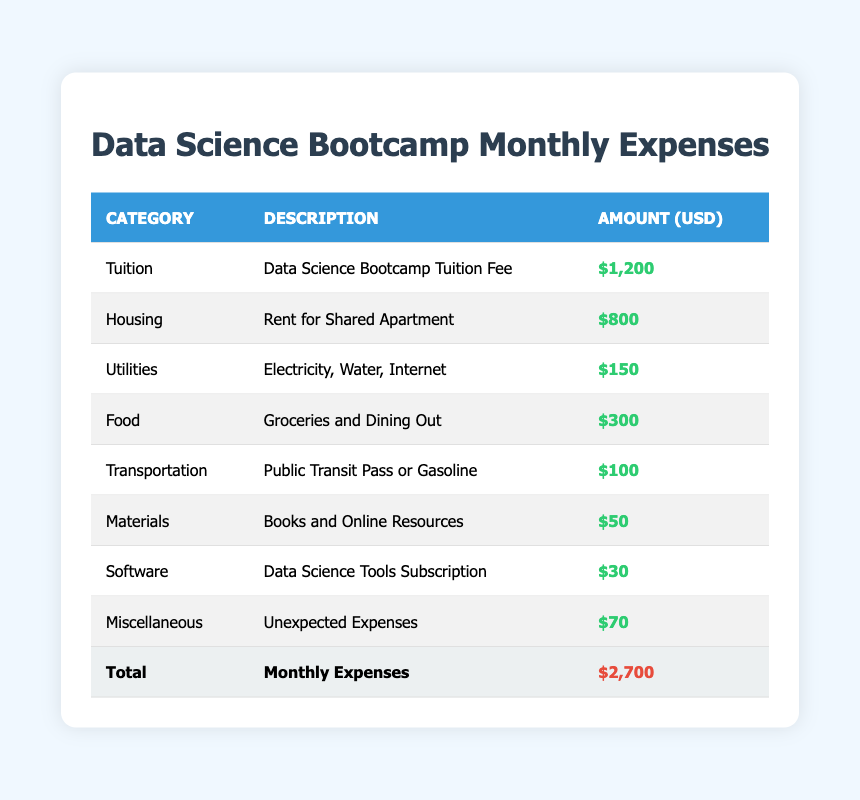What is the total amount of monthly expenses? The total amount is given in the last row of the table, where it states that the total monthly expenses amount to $2,700.
Answer: 2,700 Which category has the highest expense? By looking at the amounts listed, the tuition category has the highest expense listed at $1,200.
Answer: Tuition What is the amount spent on food? The food category shows an amount of $300, which is the direct answer from the table.
Answer: 300 Is the transportation expense higher than the software expense? The transportation expense is $100, and the software expense is $30. Since $100 is greater than $30, the answer is yes.
Answer: Yes What is the combined total of housing and utilities expenses? The housing expense is $800, and the utilities expense is $150. Adding these together gives $800 + $150 = $950.
Answer: 950 What percentage of the total monthly expenses does the tuition represent? The tuition amount is $1,200. To find the percentage it represents of the total $2,700, we calculate (1200/2700) * 100 = 44.44%.
Answer: 44.44 How much less is the amount spent on materials compared to the amount spent on food? The food expense is $300, and the materials expense is $50. The difference is calculated as $300 - $50 = $250.
Answer: 250 What is the average monthly expense across all categories? To find the average, we add all expenses (1200 + 800 + 150 + 300 + 100 + 50 + 30 + 70 = 2700) and divide by the number of categories (8). Therefore, average = 2700 / 8 = 337.5.
Answer: 337.5 Do the miscellaneous expenses exceed the software expenses? The miscellaneous expenses are $70 and the software expenses are $30. Since $70 is greater than $30, the answer is yes.
Answer: Yes 